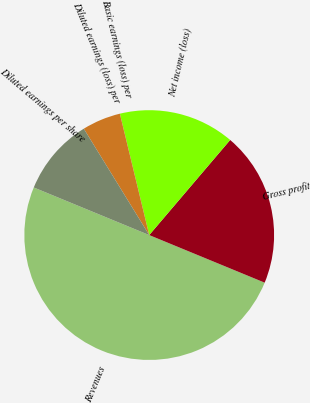Convert chart to OTSL. <chart><loc_0><loc_0><loc_500><loc_500><pie_chart><fcel>Revenues<fcel>Gross profit<fcel>Net income (loss)<fcel>Basic earnings (loss) per<fcel>Diluted earnings (loss) per<fcel>Diluted earnings per share<nl><fcel>50.0%<fcel>20.0%<fcel>15.0%<fcel>0.0%<fcel>5.0%<fcel>10.0%<nl></chart> 